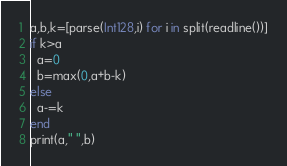Convert code to text. <code><loc_0><loc_0><loc_500><loc_500><_Julia_>a,b,k=[parse(Int128,i) for i in split(readline())]
if k>a
  a=0
  b=max(0,a+b-k)
else
  a-=k
end
print(a," ",b)</code> 